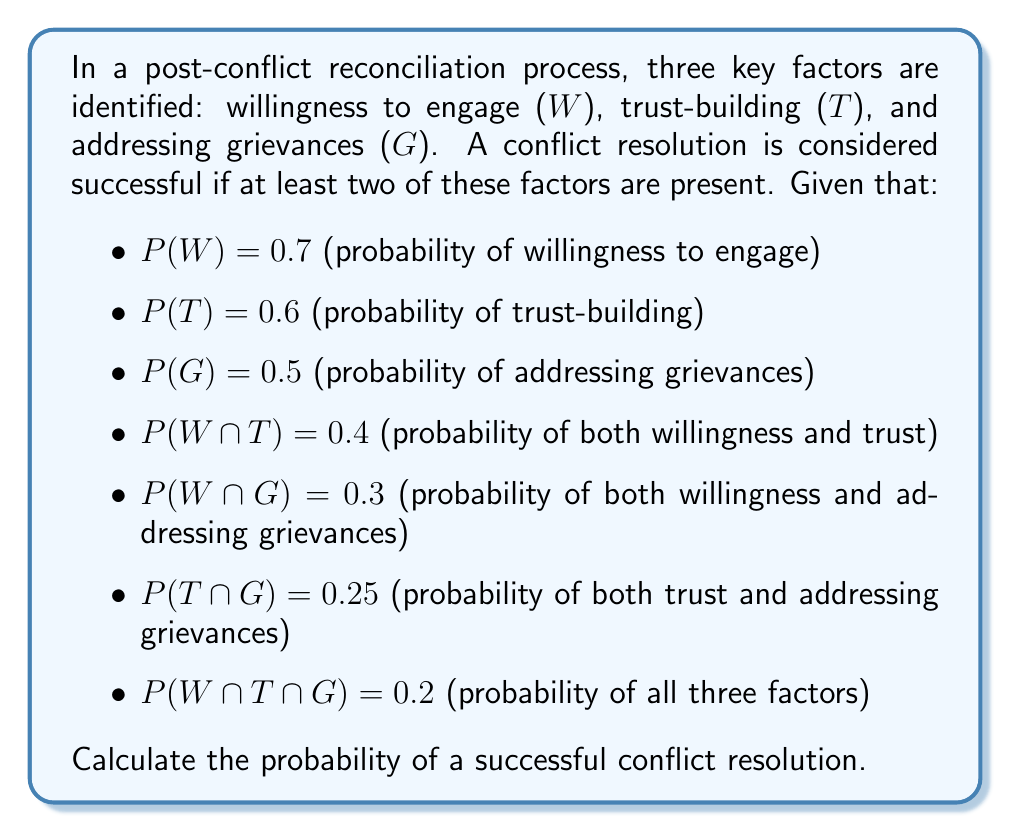Can you solve this math problem? To solve this problem, we'll use set theory and the inclusion-exclusion principle. Let's break it down step by step:

1) First, we need to find the probability of at least two factors being present. This is equivalent to the probability of the union of all combinations of two or more factors minus the probability of all three factors occurring simultaneously.

2) Let's define S as the event of successful conflict resolution. Then:

   $$P(S) = P((W ∩ T) ∪ (W ∩ G) ∪ (T ∩ G)) - P(W ∩ T ∩ G)$$

3) We're given P(W ∩ T ∩ G) = 0.2, so we just need to calculate P((W ∩ T) ∪ (W ∩ G) ∪ (T ∩ G)).

4) Using the inclusion-exclusion principle for three sets:

   $$P(A ∪ B ∪ C) = P(A) + P(B) + P(C) - P(A ∩ B) - P(A ∩ C) - P(B ∩ C) + P(A ∩ B ∩ C)$$

5) Applying this to our problem:

   $$P((W ∩ T) ∪ (W ∩ G) ∪ (T ∩ G)) = P(W ∩ T) + P(W ∩ G) + P(T ∩ G) - P(W ∩ T ∩ G)$$

6) Substituting the given probabilities:

   $$P((W ∩ T) ∪ (W ∩ G) ∪ (T ∩ G)) = 0.4 + 0.3 + 0.25 - 0.2 = 0.75$$

7) Now we can calculate P(S):

   $$P(S) = 0.75 - 0.2 = 0.55$$

Therefore, the probability of a successful conflict resolution is 0.55 or 55%.
Answer: 0.55 or 55% 